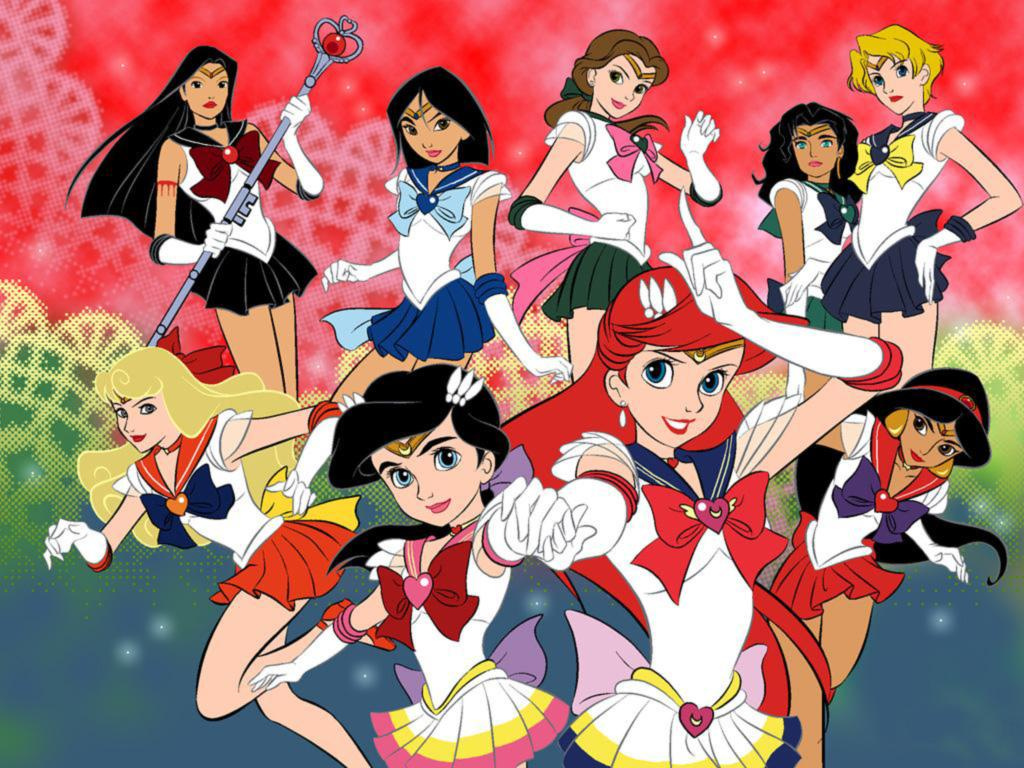What type of image is being described? The image is animated. Who or what can be seen in the image? There are women in the image. What is one of the women doing in the image? One woman is holding a stick in her hands. Can you describe the background of the image? There are designs in the background of the image. What type of bag can be seen in the image? There is no bag present in the image. How does the woman rub the stick in the image? The woman is not rubbing the stick in the image; she is simply holding it. 